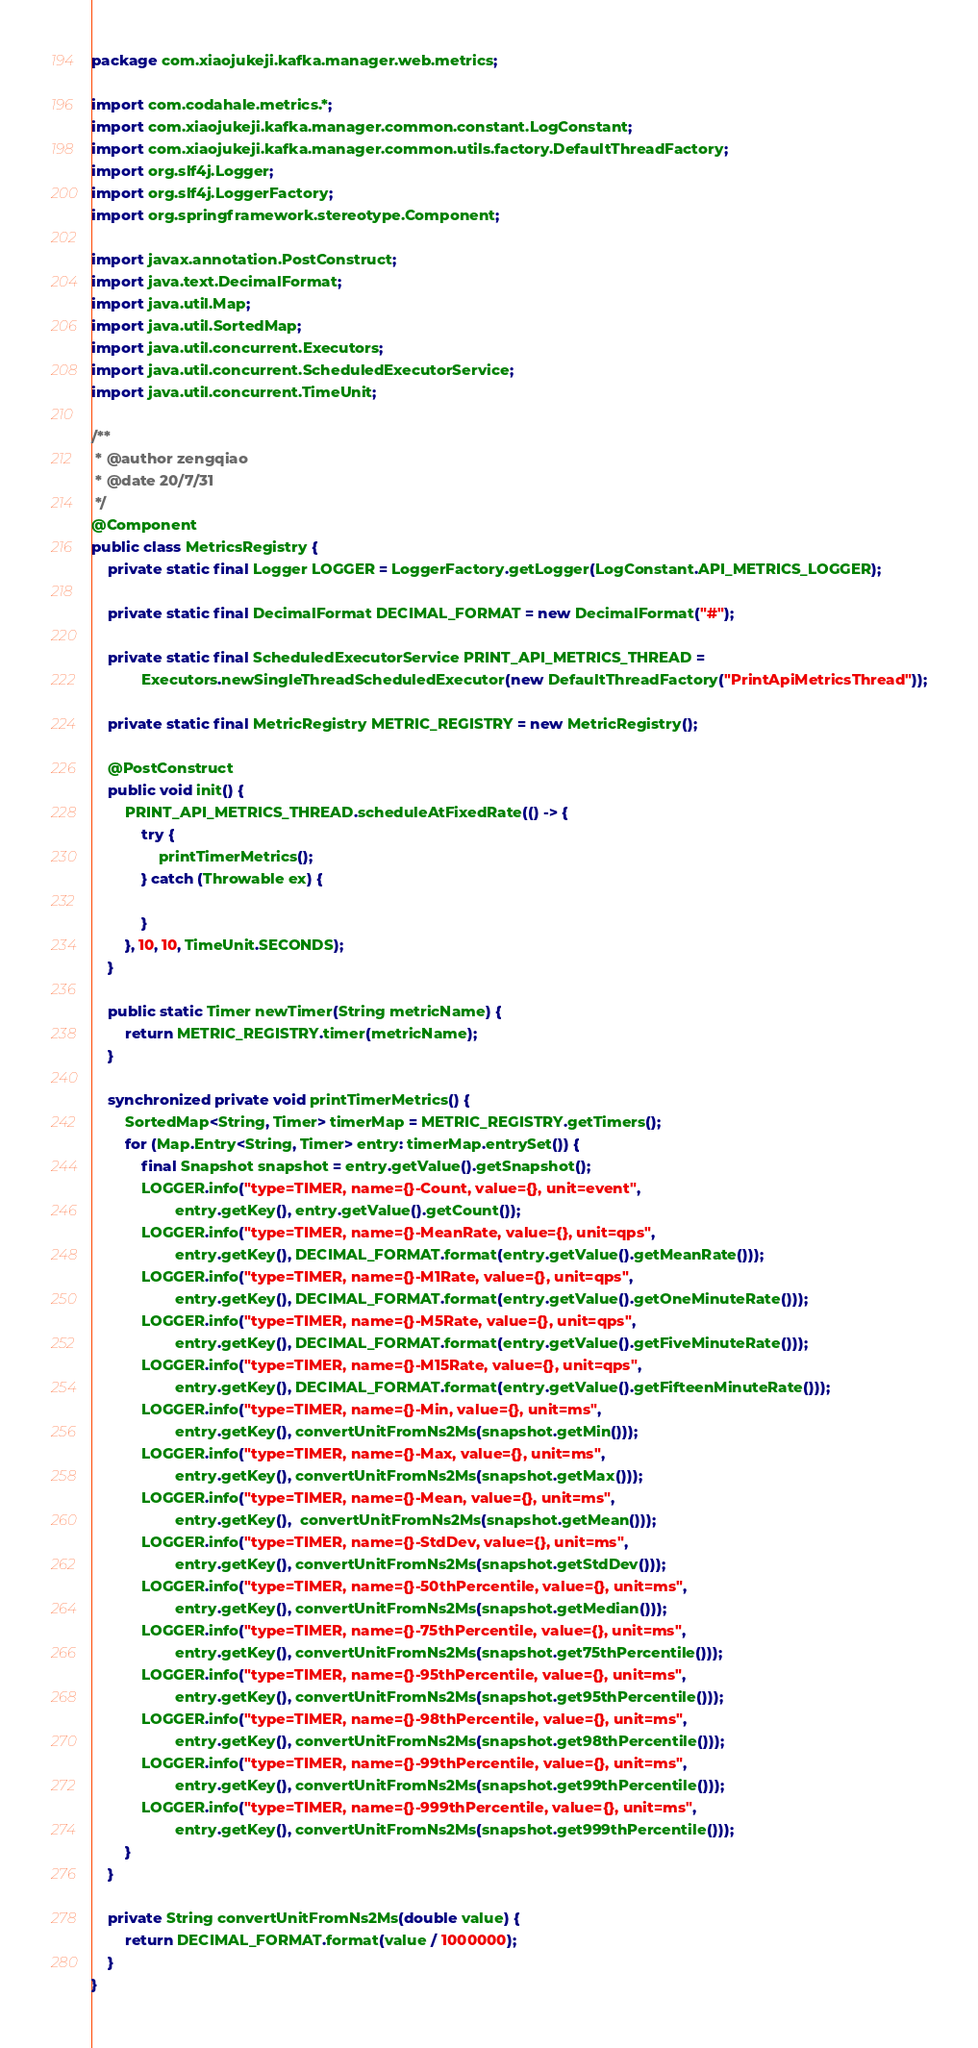<code> <loc_0><loc_0><loc_500><loc_500><_Java_>package com.xiaojukeji.kafka.manager.web.metrics;

import com.codahale.metrics.*;
import com.xiaojukeji.kafka.manager.common.constant.LogConstant;
import com.xiaojukeji.kafka.manager.common.utils.factory.DefaultThreadFactory;
import org.slf4j.Logger;
import org.slf4j.LoggerFactory;
import org.springframework.stereotype.Component;

import javax.annotation.PostConstruct;
import java.text.DecimalFormat;
import java.util.Map;
import java.util.SortedMap;
import java.util.concurrent.Executors;
import java.util.concurrent.ScheduledExecutorService;
import java.util.concurrent.TimeUnit;

/**
 * @author zengqiao
 * @date 20/7/31
 */
@Component
public class MetricsRegistry {
    private static final Logger LOGGER = LoggerFactory.getLogger(LogConstant.API_METRICS_LOGGER);

    private static final DecimalFormat DECIMAL_FORMAT = new DecimalFormat("#");

    private static final ScheduledExecutorService PRINT_API_METRICS_THREAD =
            Executors.newSingleThreadScheduledExecutor(new DefaultThreadFactory("PrintApiMetricsThread"));

    private static final MetricRegistry METRIC_REGISTRY = new MetricRegistry();

    @PostConstruct
    public void init() {
        PRINT_API_METRICS_THREAD.scheduleAtFixedRate(() -> {
            try {
                printTimerMetrics();
            } catch (Throwable ex) {

            }
        }, 10, 10, TimeUnit.SECONDS);
    }

    public static Timer newTimer(String metricName) {
        return METRIC_REGISTRY.timer(metricName);
    }

    synchronized private void printTimerMetrics() {
        SortedMap<String, Timer> timerMap = METRIC_REGISTRY.getTimers();
        for (Map.Entry<String, Timer> entry: timerMap.entrySet()) {
            final Snapshot snapshot = entry.getValue().getSnapshot();
            LOGGER.info("type=TIMER, name={}-Count, value={}, unit=event",
                    entry.getKey(), entry.getValue().getCount());
            LOGGER.info("type=TIMER, name={}-MeanRate, value={}, unit=qps",
                    entry.getKey(), DECIMAL_FORMAT.format(entry.getValue().getMeanRate()));
            LOGGER.info("type=TIMER, name={}-M1Rate, value={}, unit=qps",
                    entry.getKey(), DECIMAL_FORMAT.format(entry.getValue().getOneMinuteRate()));
            LOGGER.info("type=TIMER, name={}-M5Rate, value={}, unit=qps",
                    entry.getKey(), DECIMAL_FORMAT.format(entry.getValue().getFiveMinuteRate()));
            LOGGER.info("type=TIMER, name={}-M15Rate, value={}, unit=qps",
                    entry.getKey(), DECIMAL_FORMAT.format(entry.getValue().getFifteenMinuteRate()));
            LOGGER.info("type=TIMER, name={}-Min, value={}, unit=ms",
                    entry.getKey(), convertUnitFromNs2Ms(snapshot.getMin()));
            LOGGER.info("type=TIMER, name={}-Max, value={}, unit=ms",
                    entry.getKey(), convertUnitFromNs2Ms(snapshot.getMax()));
            LOGGER.info("type=TIMER, name={}-Mean, value={}, unit=ms",
                    entry.getKey(),  convertUnitFromNs2Ms(snapshot.getMean()));
            LOGGER.info("type=TIMER, name={}-StdDev, value={}, unit=ms",
                    entry.getKey(), convertUnitFromNs2Ms(snapshot.getStdDev()));
            LOGGER.info("type=TIMER, name={}-50thPercentile, value={}, unit=ms",
                    entry.getKey(), convertUnitFromNs2Ms(snapshot.getMedian()));
            LOGGER.info("type=TIMER, name={}-75thPercentile, value={}, unit=ms",
                    entry.getKey(), convertUnitFromNs2Ms(snapshot.get75thPercentile()));
            LOGGER.info("type=TIMER, name={}-95thPercentile, value={}, unit=ms",
                    entry.getKey(), convertUnitFromNs2Ms(snapshot.get95thPercentile()));
            LOGGER.info("type=TIMER, name={}-98thPercentile, value={}, unit=ms",
                    entry.getKey(), convertUnitFromNs2Ms(snapshot.get98thPercentile()));
            LOGGER.info("type=TIMER, name={}-99thPercentile, value={}, unit=ms",
                    entry.getKey(), convertUnitFromNs2Ms(snapshot.get99thPercentile()));
            LOGGER.info("type=TIMER, name={}-999thPercentile, value={}, unit=ms",
                    entry.getKey(), convertUnitFromNs2Ms(snapshot.get999thPercentile()));
        }
    }

    private String convertUnitFromNs2Ms(double value) {
        return DECIMAL_FORMAT.format(value / 1000000);
    }
}</code> 